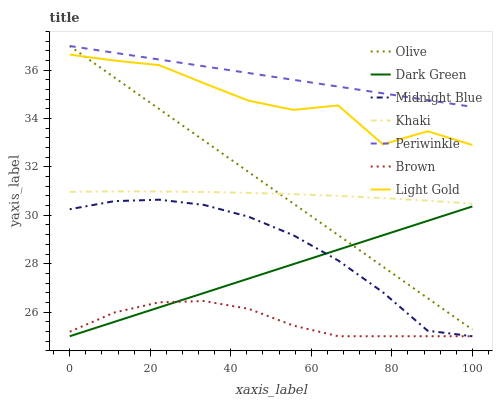Does Brown have the minimum area under the curve?
Answer yes or no. Yes. Does Periwinkle have the maximum area under the curve?
Answer yes or no. Yes. Does Khaki have the minimum area under the curve?
Answer yes or no. No. Does Khaki have the maximum area under the curve?
Answer yes or no. No. Is Periwinkle the smoothest?
Answer yes or no. Yes. Is Light Gold the roughest?
Answer yes or no. Yes. Is Khaki the smoothest?
Answer yes or no. No. Is Khaki the roughest?
Answer yes or no. No. Does Khaki have the lowest value?
Answer yes or no. No. Does Khaki have the highest value?
Answer yes or no. No. Is Brown less than Light Gold?
Answer yes or no. Yes. Is Light Gold greater than Midnight Blue?
Answer yes or no. Yes. Does Brown intersect Light Gold?
Answer yes or no. No. 